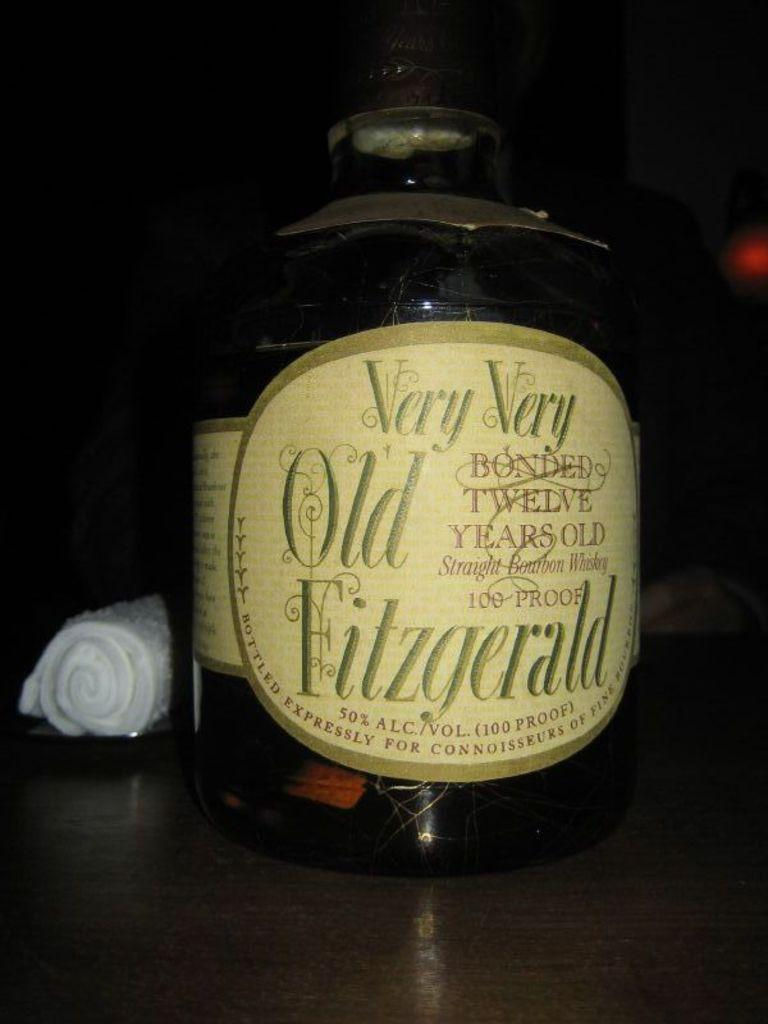Provide a one-sentence caption for the provided image. A large bottle of old Fitzgerald sits in a dark setting. 